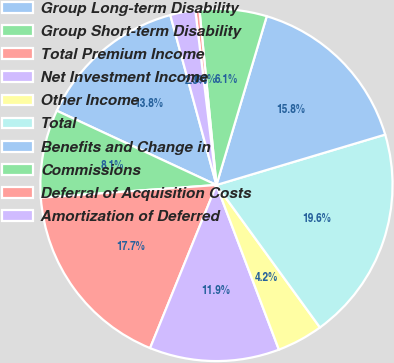<chart> <loc_0><loc_0><loc_500><loc_500><pie_chart><fcel>Group Long-term Disability<fcel>Group Short-term Disability<fcel>Total Premium Income<fcel>Net Investment Income<fcel>Other Income<fcel>Total<fcel>Benefits and Change in<fcel>Commissions<fcel>Deferral of Acquisition Costs<fcel>Amortization of Deferred<nl><fcel>13.85%<fcel>8.08%<fcel>17.7%<fcel>11.92%<fcel>4.23%<fcel>19.62%<fcel>15.77%<fcel>6.15%<fcel>0.38%<fcel>2.3%<nl></chart> 